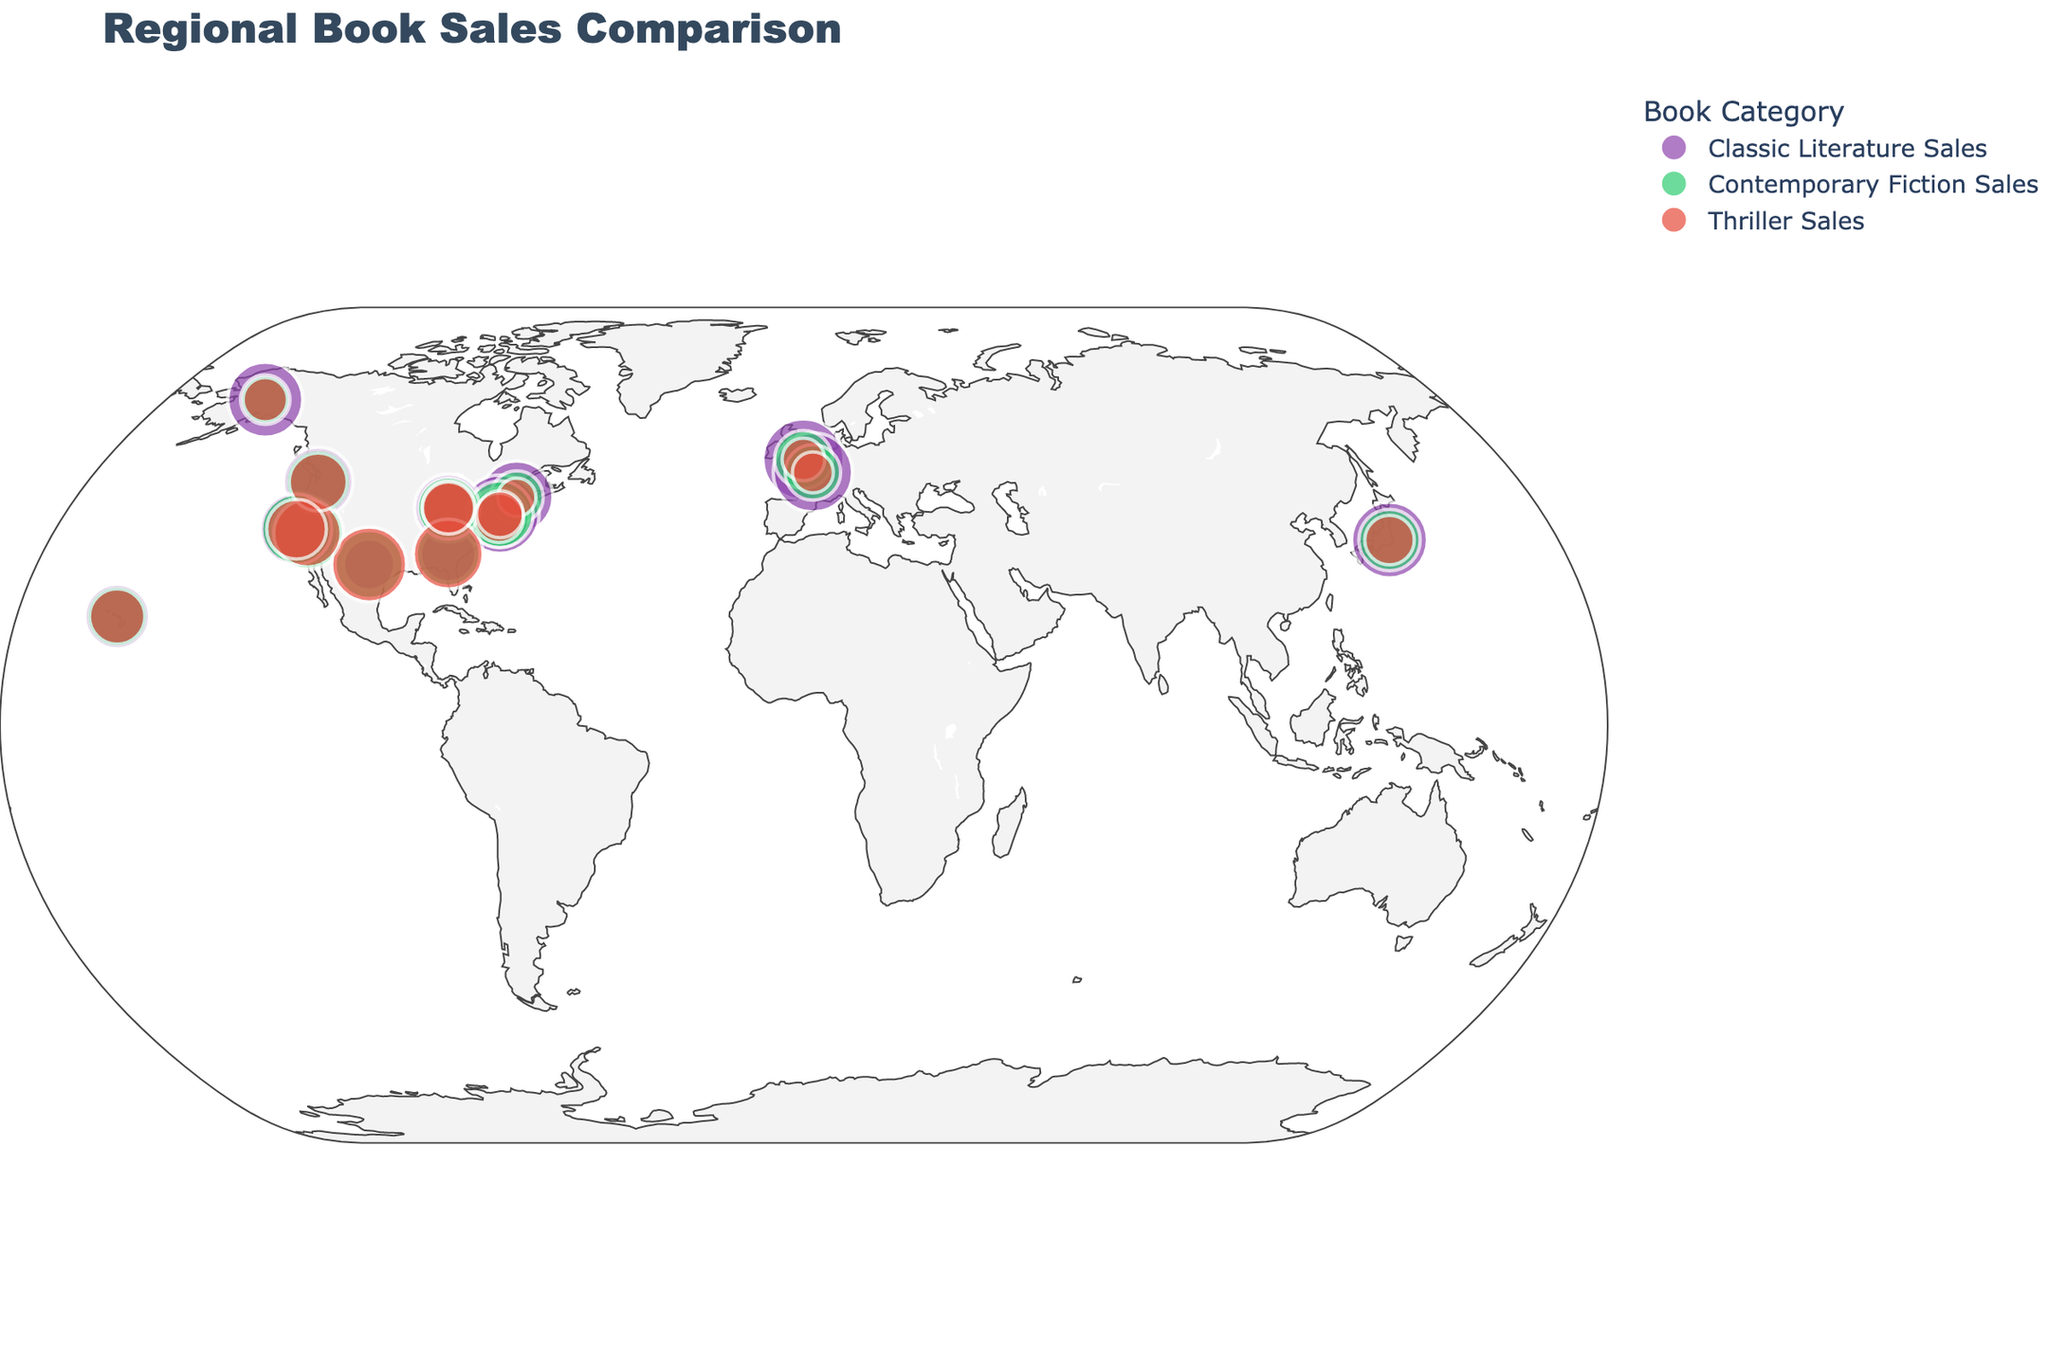What's the title of the figure? The figure has a title text which summarizes the content depicted in the figure. Look at the very top of the figure to find this information.
Answer: Regional Book Sales Comparison How many categories of book sales are represented in the figure? By observing the legend on the figure, you will see different colored markers. Each color represents a different category. Count the number of colors in the legend.
Answer: Three Which region has the highest sales of Classic Literature? Look at the size of the markers corresponding to Classic Literature Sales (likely the purple ones) across different regions. The largest marker indicates the highest sales.
Answer: London Which region has the lowest sales of Thrillers? Examine the size of the markers corresponding to Thriller Sales (likely the red ones) across different regions. The smallest marker will indicate the lowest sales.
Answer: Paris What is the difference between Contemporary Fiction Sales and Classic Literature Sales in the South? Identify the sizes of the markers for Contemporary Fiction Sales and Classic Literature Sales in the South. Subtract the size representing Classic Literature from the size representing Contemporary Fiction.
Answer: 10 In which region do Contemporary Fiction Sales exceed Classic Literature Sales by the largest margin? Compare the sizes of Contemporary Fiction and Classic Literature markers in each region. The region with the largest difference (Contemporary Fiction minus Classic Literature) is the answer.
Answer: Southwest How does the marker size for Thriller Sales in Tokyo compare to that in Chicago? Observe the sizes of the markers for Thriller Sales in Tokyo and Chicago and compare them visually to determine which is larger.
Answer: Tokyo's is larger Which regions have higher sales of Contemporary Fiction than Thriller? Compare the sizes of the markers for Contemporary Fiction Sales and Thriller Sales in each region. List the regions where the Contemporary Fiction marker is larger than the Thriller marker.
Answer: New England, Mid-Atlantic, Midwest, West Coast, New York City, Chicago, San Francisco, Tokyo How do sales of Classic Literature in the Midwest compare to those in New England? Look at the sizes of the markers for Classic Literature in the Midwest and New England, and compare them visually to see which is larger.
Answer: New England's is larger What trend can be observed in the sales of Thriller novels across different regions? Observe the sizes of the markers representing Thriller Sales across all regions. Identify any patterns such as regions with consistently larger or smaller markers.
Answer: Generally higher in the South and Southwest 